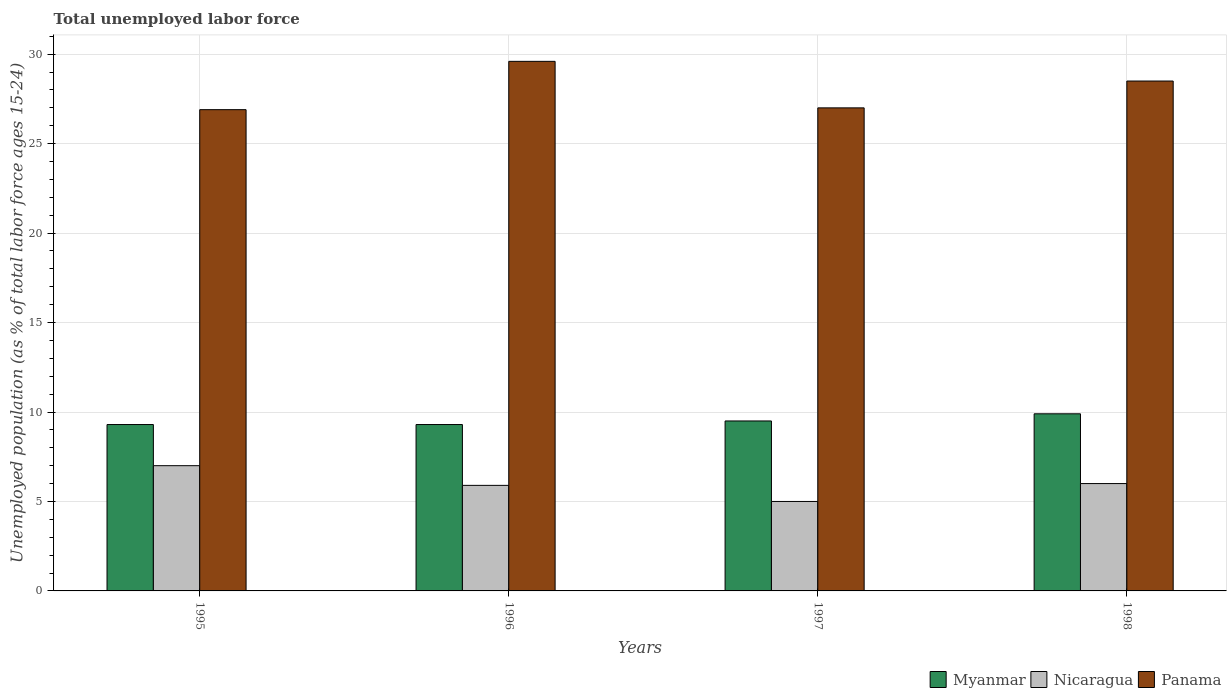How many groups of bars are there?
Keep it short and to the point. 4. What is the label of the 4th group of bars from the left?
Provide a succinct answer. 1998. In how many cases, is the number of bars for a given year not equal to the number of legend labels?
Your answer should be compact. 0. What is the percentage of unemployed population in in Myanmar in 1998?
Offer a terse response. 9.9. Across all years, what is the maximum percentage of unemployed population in in Panama?
Offer a very short reply. 29.6. Across all years, what is the minimum percentage of unemployed population in in Nicaragua?
Offer a terse response. 5. In which year was the percentage of unemployed population in in Panama maximum?
Offer a very short reply. 1996. What is the total percentage of unemployed population in in Panama in the graph?
Give a very brief answer. 112. What is the difference between the percentage of unemployed population in in Nicaragua in 1995 and that in 1996?
Your response must be concise. 1.1. What is the difference between the percentage of unemployed population in in Myanmar in 1998 and the percentage of unemployed population in in Panama in 1996?
Keep it short and to the point. -19.7. What is the average percentage of unemployed population in in Nicaragua per year?
Make the answer very short. 5.98. In the year 1996, what is the difference between the percentage of unemployed population in in Nicaragua and percentage of unemployed population in in Panama?
Offer a very short reply. -23.7. What is the ratio of the percentage of unemployed population in in Panama in 1995 to that in 1998?
Your response must be concise. 0.94. Is the percentage of unemployed population in in Panama in 1997 less than that in 1998?
Offer a terse response. Yes. What is the difference between the highest and the second highest percentage of unemployed population in in Nicaragua?
Provide a succinct answer. 1. What is the difference between the highest and the lowest percentage of unemployed population in in Myanmar?
Make the answer very short. 0.6. In how many years, is the percentage of unemployed population in in Myanmar greater than the average percentage of unemployed population in in Myanmar taken over all years?
Your answer should be very brief. 2. Is the sum of the percentage of unemployed population in in Nicaragua in 1996 and 1998 greater than the maximum percentage of unemployed population in in Myanmar across all years?
Give a very brief answer. Yes. What does the 2nd bar from the left in 1996 represents?
Ensure brevity in your answer.  Nicaragua. What does the 1st bar from the right in 1998 represents?
Provide a succinct answer. Panama. Is it the case that in every year, the sum of the percentage of unemployed population in in Panama and percentage of unemployed population in in Myanmar is greater than the percentage of unemployed population in in Nicaragua?
Ensure brevity in your answer.  Yes. How many bars are there?
Offer a terse response. 12. Are all the bars in the graph horizontal?
Provide a short and direct response. No. Are the values on the major ticks of Y-axis written in scientific E-notation?
Provide a succinct answer. No. Does the graph contain any zero values?
Your answer should be very brief. No. Where does the legend appear in the graph?
Ensure brevity in your answer.  Bottom right. How many legend labels are there?
Offer a terse response. 3. How are the legend labels stacked?
Your answer should be very brief. Horizontal. What is the title of the graph?
Offer a terse response. Total unemployed labor force. Does "Low & middle income" appear as one of the legend labels in the graph?
Your answer should be compact. No. What is the label or title of the Y-axis?
Provide a short and direct response. Unemployed population (as % of total labor force ages 15-24). What is the Unemployed population (as % of total labor force ages 15-24) of Myanmar in 1995?
Your response must be concise. 9.3. What is the Unemployed population (as % of total labor force ages 15-24) in Nicaragua in 1995?
Provide a succinct answer. 7. What is the Unemployed population (as % of total labor force ages 15-24) of Panama in 1995?
Keep it short and to the point. 26.9. What is the Unemployed population (as % of total labor force ages 15-24) in Myanmar in 1996?
Keep it short and to the point. 9.3. What is the Unemployed population (as % of total labor force ages 15-24) in Nicaragua in 1996?
Offer a terse response. 5.9. What is the Unemployed population (as % of total labor force ages 15-24) in Panama in 1996?
Your response must be concise. 29.6. What is the Unemployed population (as % of total labor force ages 15-24) in Myanmar in 1997?
Provide a succinct answer. 9.5. What is the Unemployed population (as % of total labor force ages 15-24) in Panama in 1997?
Your answer should be very brief. 27. What is the Unemployed population (as % of total labor force ages 15-24) in Myanmar in 1998?
Your response must be concise. 9.9. What is the Unemployed population (as % of total labor force ages 15-24) in Panama in 1998?
Your answer should be compact. 28.5. Across all years, what is the maximum Unemployed population (as % of total labor force ages 15-24) in Myanmar?
Your answer should be compact. 9.9. Across all years, what is the maximum Unemployed population (as % of total labor force ages 15-24) in Panama?
Provide a short and direct response. 29.6. Across all years, what is the minimum Unemployed population (as % of total labor force ages 15-24) in Myanmar?
Provide a short and direct response. 9.3. Across all years, what is the minimum Unemployed population (as % of total labor force ages 15-24) in Panama?
Provide a short and direct response. 26.9. What is the total Unemployed population (as % of total labor force ages 15-24) in Nicaragua in the graph?
Keep it short and to the point. 23.9. What is the total Unemployed population (as % of total labor force ages 15-24) of Panama in the graph?
Keep it short and to the point. 112. What is the difference between the Unemployed population (as % of total labor force ages 15-24) of Panama in 1995 and that in 1996?
Ensure brevity in your answer.  -2.7. What is the difference between the Unemployed population (as % of total labor force ages 15-24) of Myanmar in 1995 and that in 1998?
Your response must be concise. -0.6. What is the difference between the Unemployed population (as % of total labor force ages 15-24) of Nicaragua in 1995 and that in 1998?
Your response must be concise. 1. What is the difference between the Unemployed population (as % of total labor force ages 15-24) of Panama in 1995 and that in 1998?
Provide a short and direct response. -1.6. What is the difference between the Unemployed population (as % of total labor force ages 15-24) of Myanmar in 1996 and that in 1997?
Keep it short and to the point. -0.2. What is the difference between the Unemployed population (as % of total labor force ages 15-24) of Panama in 1996 and that in 1997?
Offer a terse response. 2.6. What is the difference between the Unemployed population (as % of total labor force ages 15-24) in Myanmar in 1996 and that in 1998?
Ensure brevity in your answer.  -0.6. What is the difference between the Unemployed population (as % of total labor force ages 15-24) of Panama in 1996 and that in 1998?
Provide a short and direct response. 1.1. What is the difference between the Unemployed population (as % of total labor force ages 15-24) of Nicaragua in 1997 and that in 1998?
Offer a very short reply. -1. What is the difference between the Unemployed population (as % of total labor force ages 15-24) of Panama in 1997 and that in 1998?
Your response must be concise. -1.5. What is the difference between the Unemployed population (as % of total labor force ages 15-24) of Myanmar in 1995 and the Unemployed population (as % of total labor force ages 15-24) of Nicaragua in 1996?
Ensure brevity in your answer.  3.4. What is the difference between the Unemployed population (as % of total labor force ages 15-24) in Myanmar in 1995 and the Unemployed population (as % of total labor force ages 15-24) in Panama in 1996?
Ensure brevity in your answer.  -20.3. What is the difference between the Unemployed population (as % of total labor force ages 15-24) in Nicaragua in 1995 and the Unemployed population (as % of total labor force ages 15-24) in Panama in 1996?
Keep it short and to the point. -22.6. What is the difference between the Unemployed population (as % of total labor force ages 15-24) in Myanmar in 1995 and the Unemployed population (as % of total labor force ages 15-24) in Panama in 1997?
Offer a very short reply. -17.7. What is the difference between the Unemployed population (as % of total labor force ages 15-24) in Myanmar in 1995 and the Unemployed population (as % of total labor force ages 15-24) in Nicaragua in 1998?
Your answer should be very brief. 3.3. What is the difference between the Unemployed population (as % of total labor force ages 15-24) in Myanmar in 1995 and the Unemployed population (as % of total labor force ages 15-24) in Panama in 1998?
Keep it short and to the point. -19.2. What is the difference between the Unemployed population (as % of total labor force ages 15-24) in Nicaragua in 1995 and the Unemployed population (as % of total labor force ages 15-24) in Panama in 1998?
Give a very brief answer. -21.5. What is the difference between the Unemployed population (as % of total labor force ages 15-24) of Myanmar in 1996 and the Unemployed population (as % of total labor force ages 15-24) of Panama in 1997?
Your answer should be compact. -17.7. What is the difference between the Unemployed population (as % of total labor force ages 15-24) of Nicaragua in 1996 and the Unemployed population (as % of total labor force ages 15-24) of Panama in 1997?
Provide a succinct answer. -21.1. What is the difference between the Unemployed population (as % of total labor force ages 15-24) of Myanmar in 1996 and the Unemployed population (as % of total labor force ages 15-24) of Nicaragua in 1998?
Provide a short and direct response. 3.3. What is the difference between the Unemployed population (as % of total labor force ages 15-24) in Myanmar in 1996 and the Unemployed population (as % of total labor force ages 15-24) in Panama in 1998?
Offer a very short reply. -19.2. What is the difference between the Unemployed population (as % of total labor force ages 15-24) in Nicaragua in 1996 and the Unemployed population (as % of total labor force ages 15-24) in Panama in 1998?
Give a very brief answer. -22.6. What is the difference between the Unemployed population (as % of total labor force ages 15-24) of Nicaragua in 1997 and the Unemployed population (as % of total labor force ages 15-24) of Panama in 1998?
Offer a terse response. -23.5. What is the average Unemployed population (as % of total labor force ages 15-24) in Myanmar per year?
Keep it short and to the point. 9.5. What is the average Unemployed population (as % of total labor force ages 15-24) of Nicaragua per year?
Keep it short and to the point. 5.97. What is the average Unemployed population (as % of total labor force ages 15-24) in Panama per year?
Keep it short and to the point. 28. In the year 1995, what is the difference between the Unemployed population (as % of total labor force ages 15-24) in Myanmar and Unemployed population (as % of total labor force ages 15-24) in Panama?
Offer a terse response. -17.6. In the year 1995, what is the difference between the Unemployed population (as % of total labor force ages 15-24) of Nicaragua and Unemployed population (as % of total labor force ages 15-24) of Panama?
Ensure brevity in your answer.  -19.9. In the year 1996, what is the difference between the Unemployed population (as % of total labor force ages 15-24) of Myanmar and Unemployed population (as % of total labor force ages 15-24) of Panama?
Your response must be concise. -20.3. In the year 1996, what is the difference between the Unemployed population (as % of total labor force ages 15-24) of Nicaragua and Unemployed population (as % of total labor force ages 15-24) of Panama?
Offer a terse response. -23.7. In the year 1997, what is the difference between the Unemployed population (as % of total labor force ages 15-24) of Myanmar and Unemployed population (as % of total labor force ages 15-24) of Nicaragua?
Ensure brevity in your answer.  4.5. In the year 1997, what is the difference between the Unemployed population (as % of total labor force ages 15-24) of Myanmar and Unemployed population (as % of total labor force ages 15-24) of Panama?
Make the answer very short. -17.5. In the year 1997, what is the difference between the Unemployed population (as % of total labor force ages 15-24) in Nicaragua and Unemployed population (as % of total labor force ages 15-24) in Panama?
Your response must be concise. -22. In the year 1998, what is the difference between the Unemployed population (as % of total labor force ages 15-24) in Myanmar and Unemployed population (as % of total labor force ages 15-24) in Panama?
Your response must be concise. -18.6. In the year 1998, what is the difference between the Unemployed population (as % of total labor force ages 15-24) in Nicaragua and Unemployed population (as % of total labor force ages 15-24) in Panama?
Your response must be concise. -22.5. What is the ratio of the Unemployed population (as % of total labor force ages 15-24) of Nicaragua in 1995 to that in 1996?
Your answer should be compact. 1.19. What is the ratio of the Unemployed population (as % of total labor force ages 15-24) of Panama in 1995 to that in 1996?
Offer a very short reply. 0.91. What is the ratio of the Unemployed population (as % of total labor force ages 15-24) in Myanmar in 1995 to that in 1997?
Make the answer very short. 0.98. What is the ratio of the Unemployed population (as % of total labor force ages 15-24) of Myanmar in 1995 to that in 1998?
Your answer should be very brief. 0.94. What is the ratio of the Unemployed population (as % of total labor force ages 15-24) of Panama in 1995 to that in 1998?
Your answer should be very brief. 0.94. What is the ratio of the Unemployed population (as % of total labor force ages 15-24) in Myanmar in 1996 to that in 1997?
Provide a succinct answer. 0.98. What is the ratio of the Unemployed population (as % of total labor force ages 15-24) of Nicaragua in 1996 to that in 1997?
Offer a terse response. 1.18. What is the ratio of the Unemployed population (as % of total labor force ages 15-24) in Panama in 1996 to that in 1997?
Make the answer very short. 1.1. What is the ratio of the Unemployed population (as % of total labor force ages 15-24) in Myanmar in 1996 to that in 1998?
Provide a short and direct response. 0.94. What is the ratio of the Unemployed population (as % of total labor force ages 15-24) of Nicaragua in 1996 to that in 1998?
Provide a short and direct response. 0.98. What is the ratio of the Unemployed population (as % of total labor force ages 15-24) in Panama in 1996 to that in 1998?
Ensure brevity in your answer.  1.04. What is the ratio of the Unemployed population (as % of total labor force ages 15-24) of Myanmar in 1997 to that in 1998?
Provide a succinct answer. 0.96. What is the ratio of the Unemployed population (as % of total labor force ages 15-24) in Nicaragua in 1997 to that in 1998?
Give a very brief answer. 0.83. What is the ratio of the Unemployed population (as % of total labor force ages 15-24) of Panama in 1997 to that in 1998?
Provide a short and direct response. 0.95. What is the difference between the highest and the second highest Unemployed population (as % of total labor force ages 15-24) of Myanmar?
Your response must be concise. 0.4. What is the difference between the highest and the lowest Unemployed population (as % of total labor force ages 15-24) in Myanmar?
Keep it short and to the point. 0.6. What is the difference between the highest and the lowest Unemployed population (as % of total labor force ages 15-24) in Panama?
Your answer should be compact. 2.7. 